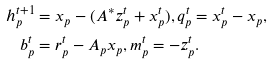Convert formula to latex. <formula><loc_0><loc_0><loc_500><loc_500>h _ { p } ^ { t + 1 } & = x _ { p } - ( A ^ { * } z _ { p } ^ { t } + x _ { p } ^ { t } ) , q _ { p } ^ { t } = x _ { p } ^ { t } - x _ { p } , \\ b _ { p } ^ { t } & = r _ { p } ^ { t } - A _ { p } x _ { p } , m _ { p } ^ { t } = - z _ { p } ^ { t } .</formula> 